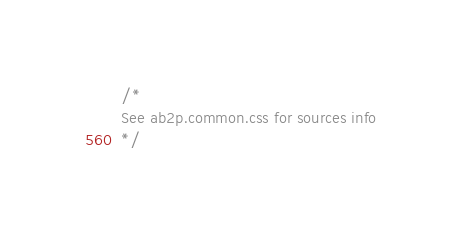Convert code to text. <code><loc_0><loc_0><loc_500><loc_500><_CSS_>/*
See ab2p.common.css for sources info
*/</code> 